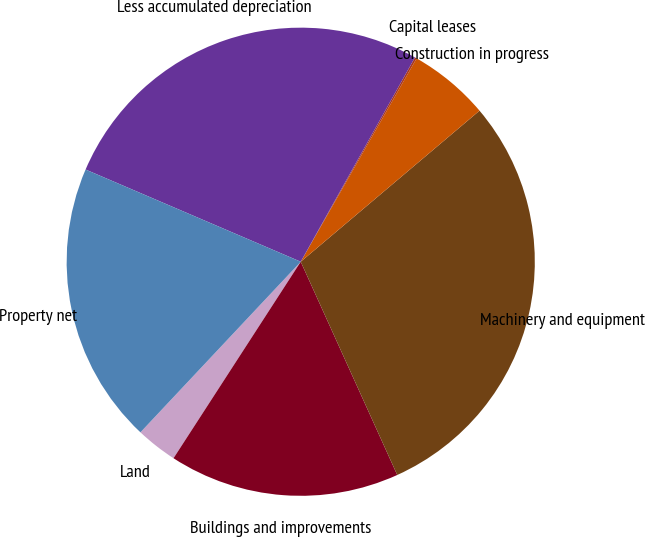<chart> <loc_0><loc_0><loc_500><loc_500><pie_chart><fcel>Land<fcel>Buildings and improvements<fcel>Machinery and equipment<fcel>Construction in progress<fcel>Capital leases<fcel>Less accumulated depreciation<fcel>Property net<nl><fcel>2.86%<fcel>15.91%<fcel>29.4%<fcel>5.59%<fcel>0.13%<fcel>26.67%<fcel>19.44%<nl></chart> 